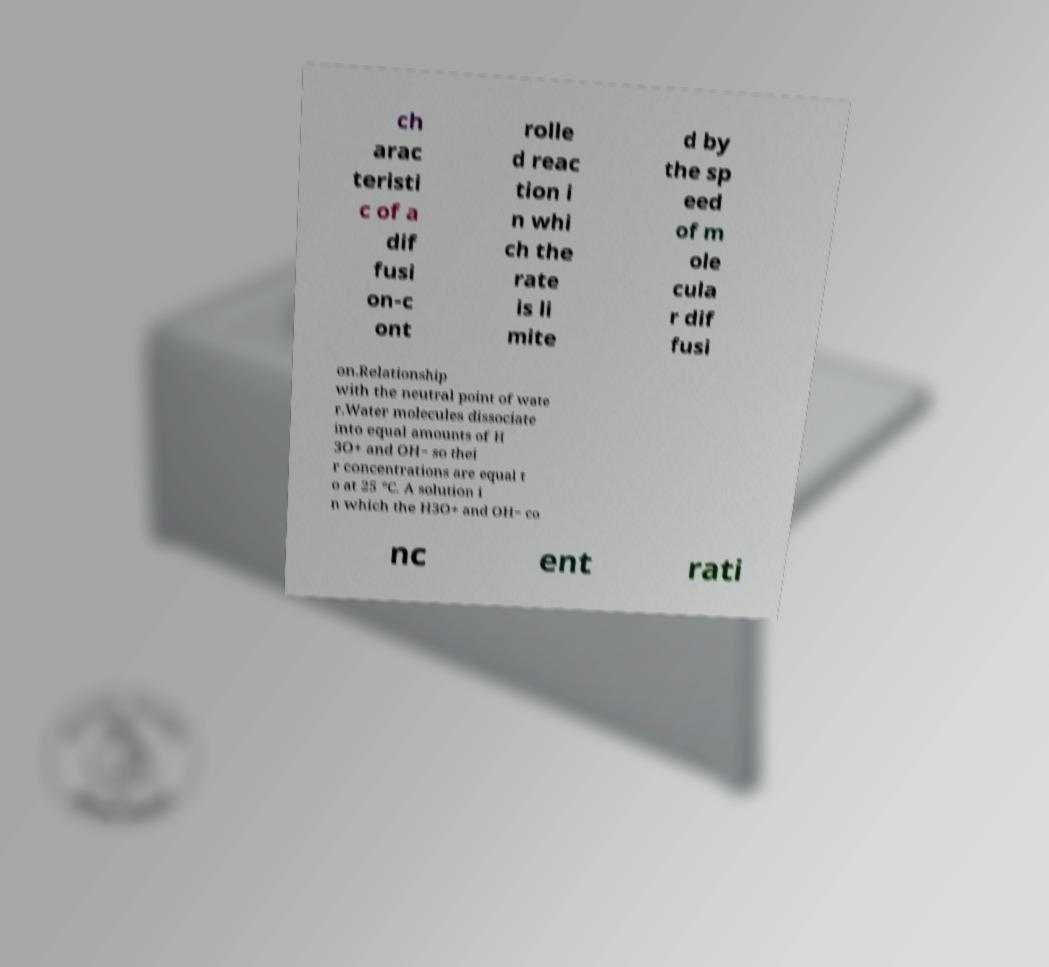Please identify and transcribe the text found in this image. ch arac teristi c of a dif fusi on-c ont rolle d reac tion i n whi ch the rate is li mite d by the sp eed of m ole cula r dif fusi on.Relationship with the neutral point of wate r.Water molecules dissociate into equal amounts of H 3O+ and OH− so thei r concentrations are equal t o at 25 °C. A solution i n which the H3O+ and OH− co nc ent rati 